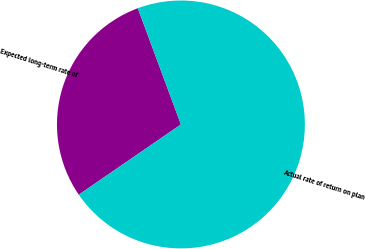Convert chart. <chart><loc_0><loc_0><loc_500><loc_500><pie_chart><fcel>Expected long-term rate of<fcel>Actual rate of return on plan<nl><fcel>28.93%<fcel>71.07%<nl></chart> 